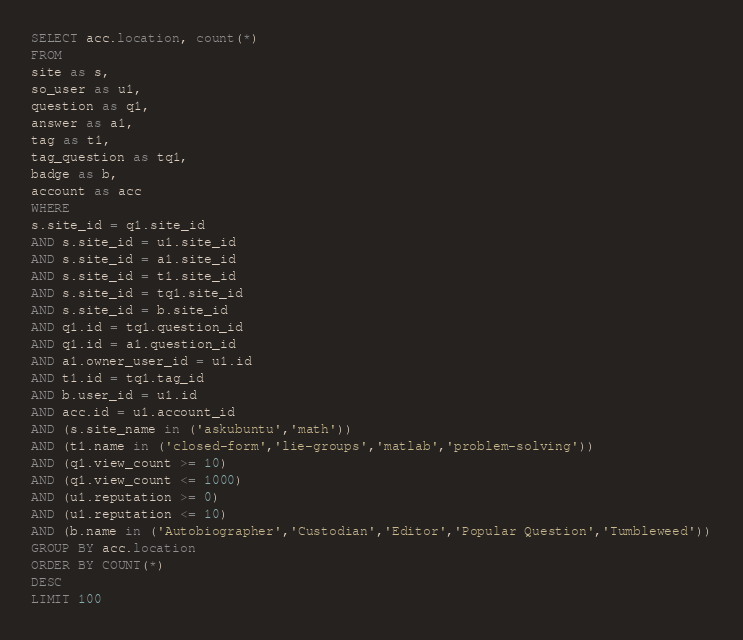Convert code to text. <code><loc_0><loc_0><loc_500><loc_500><_SQL_>SELECT acc.location, count(*)
FROM
site as s,
so_user as u1,
question as q1,
answer as a1,
tag as t1,
tag_question as tq1,
badge as b,
account as acc
WHERE
s.site_id = q1.site_id
AND s.site_id = u1.site_id
AND s.site_id = a1.site_id
AND s.site_id = t1.site_id
AND s.site_id = tq1.site_id
AND s.site_id = b.site_id
AND q1.id = tq1.question_id
AND q1.id = a1.question_id
AND a1.owner_user_id = u1.id
AND t1.id = tq1.tag_id
AND b.user_id = u1.id
AND acc.id = u1.account_id
AND (s.site_name in ('askubuntu','math'))
AND (t1.name in ('closed-form','lie-groups','matlab','problem-solving'))
AND (q1.view_count >= 10)
AND (q1.view_count <= 1000)
AND (u1.reputation >= 0)
AND (u1.reputation <= 10)
AND (b.name in ('Autobiographer','Custodian','Editor','Popular Question','Tumbleweed'))
GROUP BY acc.location
ORDER BY COUNT(*)
DESC
LIMIT 100
</code> 